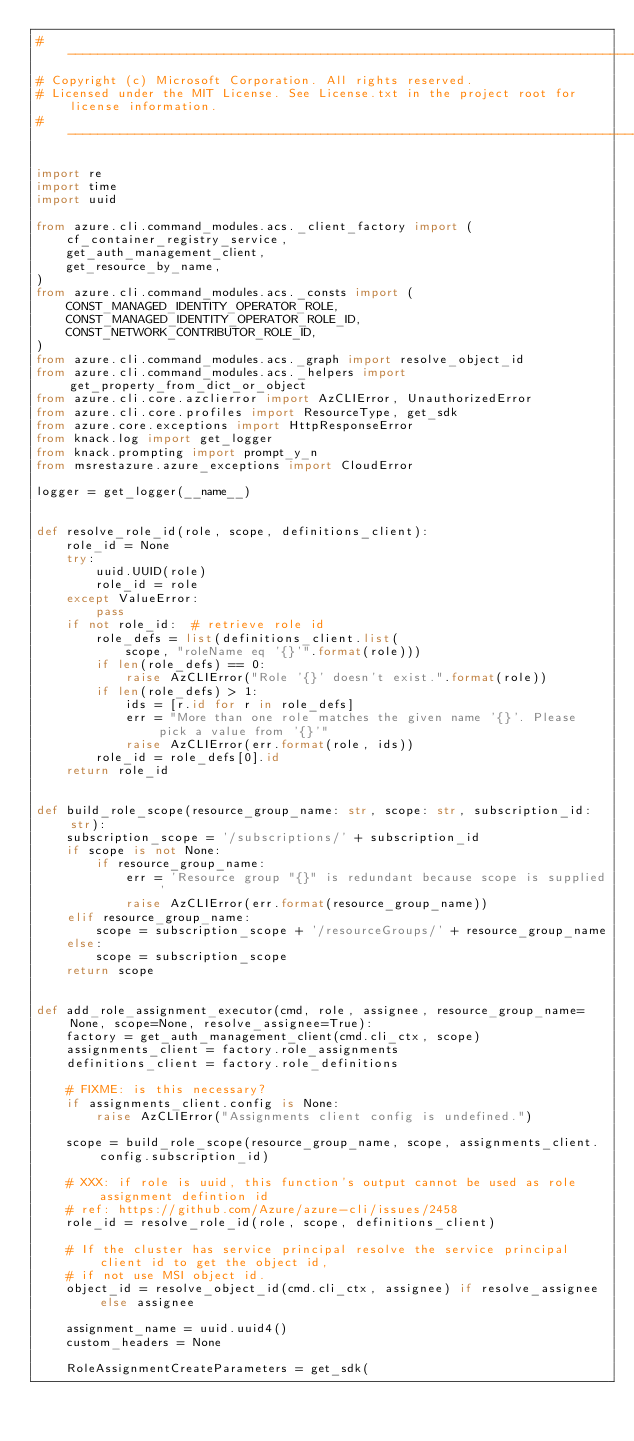<code> <loc_0><loc_0><loc_500><loc_500><_Python_># --------------------------------------------------------------------------------------------
# Copyright (c) Microsoft Corporation. All rights reserved.
# Licensed under the MIT License. See License.txt in the project root for license information.
# --------------------------------------------------------------------------------------------

import re
import time
import uuid

from azure.cli.command_modules.acs._client_factory import (
    cf_container_registry_service,
    get_auth_management_client,
    get_resource_by_name,
)
from azure.cli.command_modules.acs._consts import (
    CONST_MANAGED_IDENTITY_OPERATOR_ROLE,
    CONST_MANAGED_IDENTITY_OPERATOR_ROLE_ID,
    CONST_NETWORK_CONTRIBUTOR_ROLE_ID,
)
from azure.cli.command_modules.acs._graph import resolve_object_id
from azure.cli.command_modules.acs._helpers import get_property_from_dict_or_object
from azure.cli.core.azclierror import AzCLIError, UnauthorizedError
from azure.cli.core.profiles import ResourceType, get_sdk
from azure.core.exceptions import HttpResponseError
from knack.log import get_logger
from knack.prompting import prompt_y_n
from msrestazure.azure_exceptions import CloudError

logger = get_logger(__name__)


def resolve_role_id(role, scope, definitions_client):
    role_id = None
    try:
        uuid.UUID(role)
        role_id = role
    except ValueError:
        pass
    if not role_id:  # retrieve role id
        role_defs = list(definitions_client.list(
            scope, "roleName eq '{}'".format(role)))
        if len(role_defs) == 0:
            raise AzCLIError("Role '{}' doesn't exist.".format(role))
        if len(role_defs) > 1:
            ids = [r.id for r in role_defs]
            err = "More than one role matches the given name '{}'. Please pick a value from '{}'"
            raise AzCLIError(err.format(role, ids))
        role_id = role_defs[0].id
    return role_id


def build_role_scope(resource_group_name: str, scope: str, subscription_id: str):
    subscription_scope = '/subscriptions/' + subscription_id
    if scope is not None:
        if resource_group_name:
            err = 'Resource group "{}" is redundant because scope is supplied'
            raise AzCLIError(err.format(resource_group_name))
    elif resource_group_name:
        scope = subscription_scope + '/resourceGroups/' + resource_group_name
    else:
        scope = subscription_scope
    return scope


def add_role_assignment_executor(cmd, role, assignee, resource_group_name=None, scope=None, resolve_assignee=True):
    factory = get_auth_management_client(cmd.cli_ctx, scope)
    assignments_client = factory.role_assignments
    definitions_client = factory.role_definitions

    # FIXME: is this necessary?
    if assignments_client.config is None:
        raise AzCLIError("Assignments client config is undefined.")

    scope = build_role_scope(resource_group_name, scope, assignments_client.config.subscription_id)

    # XXX: if role is uuid, this function's output cannot be used as role assignment defintion id
    # ref: https://github.com/Azure/azure-cli/issues/2458
    role_id = resolve_role_id(role, scope, definitions_client)

    # If the cluster has service principal resolve the service principal client id to get the object id,
    # if not use MSI object id.
    object_id = resolve_object_id(cmd.cli_ctx, assignee) if resolve_assignee else assignee

    assignment_name = uuid.uuid4()
    custom_headers = None

    RoleAssignmentCreateParameters = get_sdk(</code> 